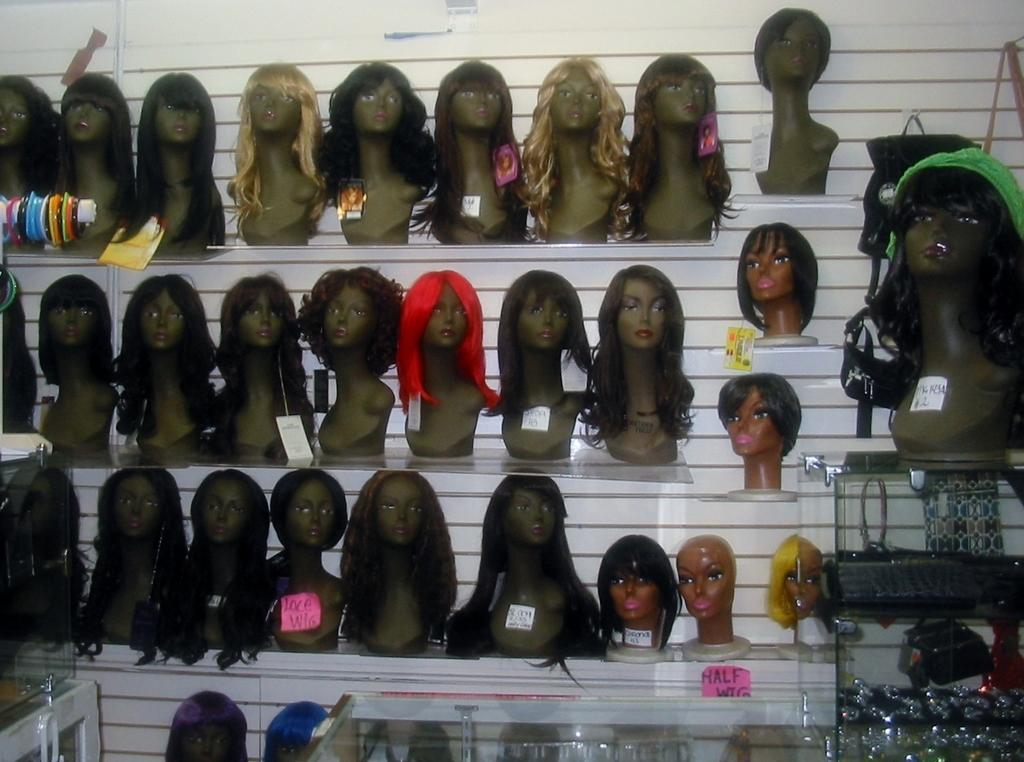What can be seen in the image that is used for displaying items? There are racks in the image that are used for displaying items. What type of items are displayed on the racks? The racks contain mannequins in the image. What are the tags used for in the image? The tags in the image are likely used for labeling or identifying the displayed items. How many rabbits can be seen interacting with the mannequins in the image? There are no rabbits present in the image; it features racks with mannequins and tags. What type of transport is used to move the mannequins in the image? There is no transport visible in the image; it only shows racks, mannequins, and tags. 